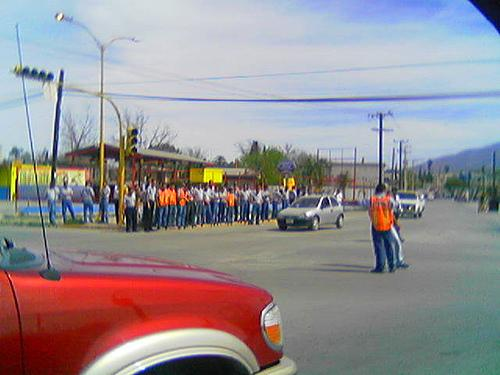What are these people doing here? Please explain your reasoning. awaiting ride. The people want a ride. 